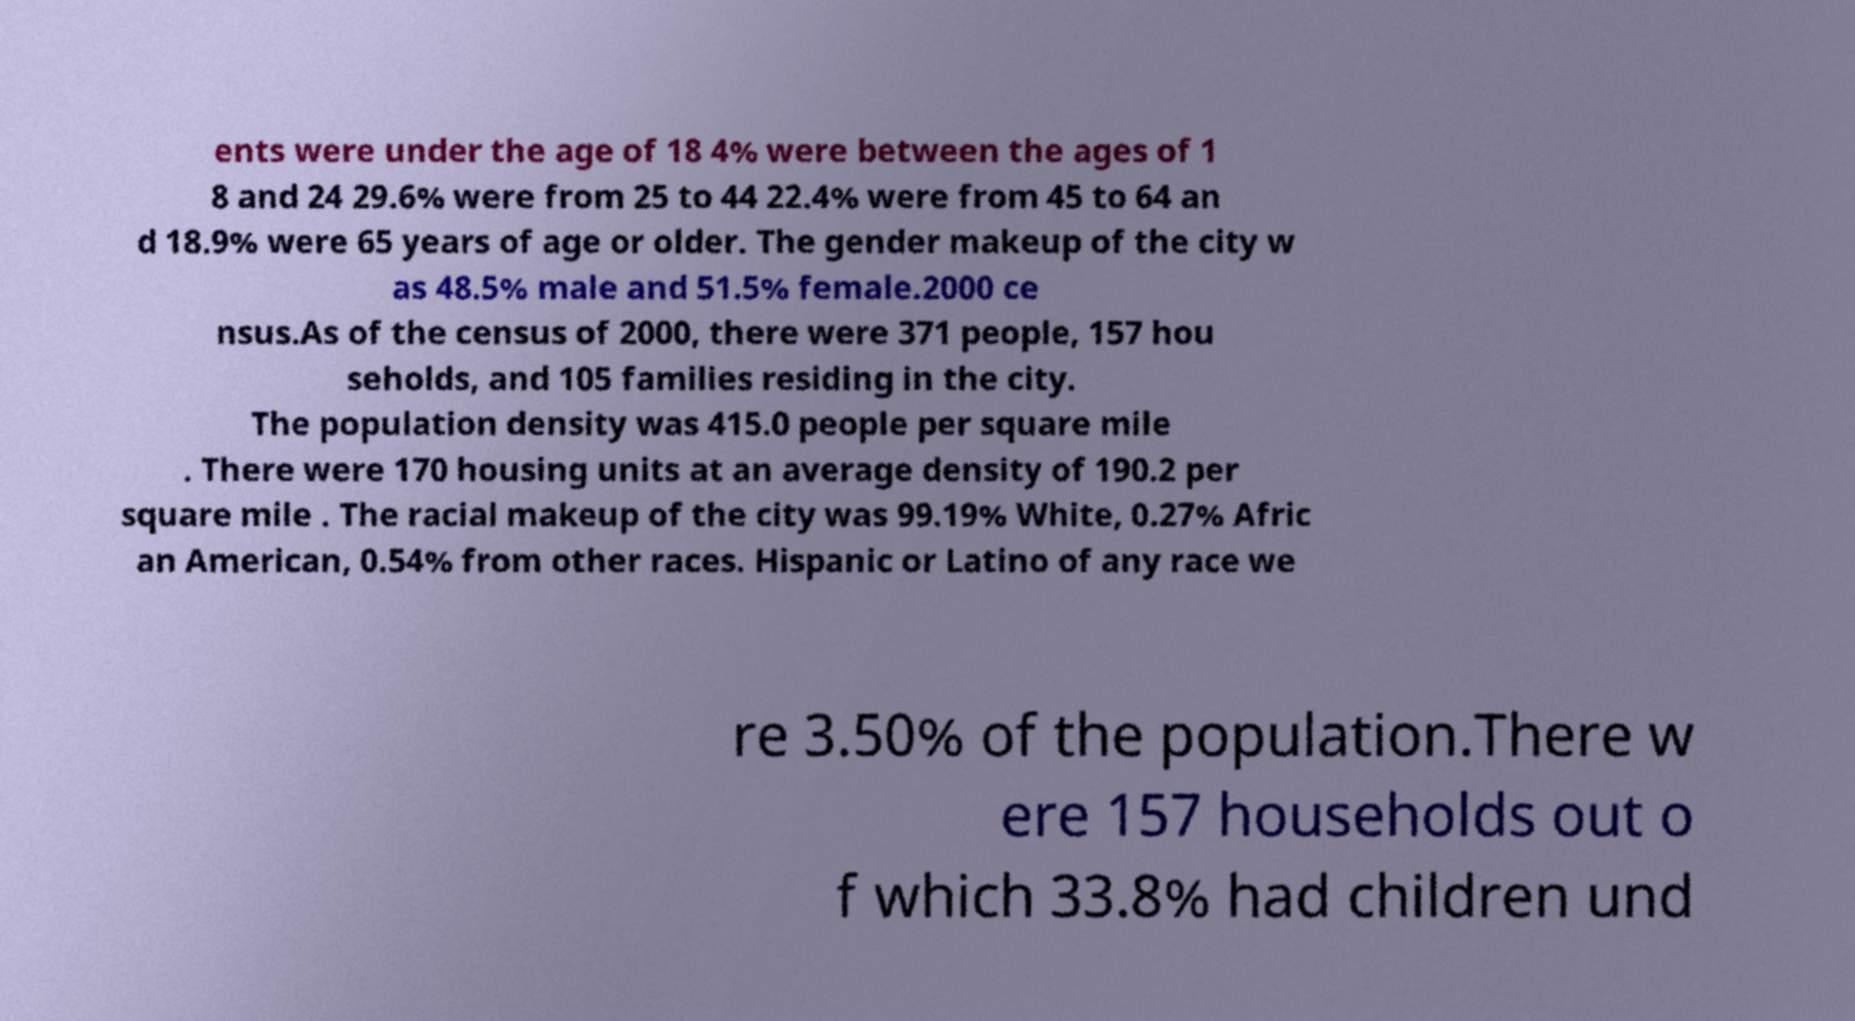What messages or text are displayed in this image? I need them in a readable, typed format. ents were under the age of 18 4% were between the ages of 1 8 and 24 29.6% were from 25 to 44 22.4% were from 45 to 64 an d 18.9% were 65 years of age or older. The gender makeup of the city w as 48.5% male and 51.5% female.2000 ce nsus.As of the census of 2000, there were 371 people, 157 hou seholds, and 105 families residing in the city. The population density was 415.0 people per square mile . There were 170 housing units at an average density of 190.2 per square mile . The racial makeup of the city was 99.19% White, 0.27% Afric an American, 0.54% from other races. Hispanic or Latino of any race we re 3.50% of the population.There w ere 157 households out o f which 33.8% had children und 